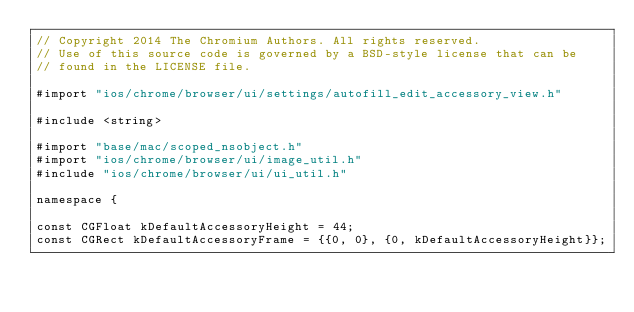<code> <loc_0><loc_0><loc_500><loc_500><_ObjectiveC_>// Copyright 2014 The Chromium Authors. All rights reserved.
// Use of this source code is governed by a BSD-style license that can be
// found in the LICENSE file.

#import "ios/chrome/browser/ui/settings/autofill_edit_accessory_view.h"

#include <string>

#import "base/mac/scoped_nsobject.h"
#import "ios/chrome/browser/ui/image_util.h"
#include "ios/chrome/browser/ui/ui_util.h"

namespace {

const CGFloat kDefaultAccessoryHeight = 44;
const CGRect kDefaultAccessoryFrame = {{0, 0}, {0, kDefaultAccessoryHeight}};
</code> 